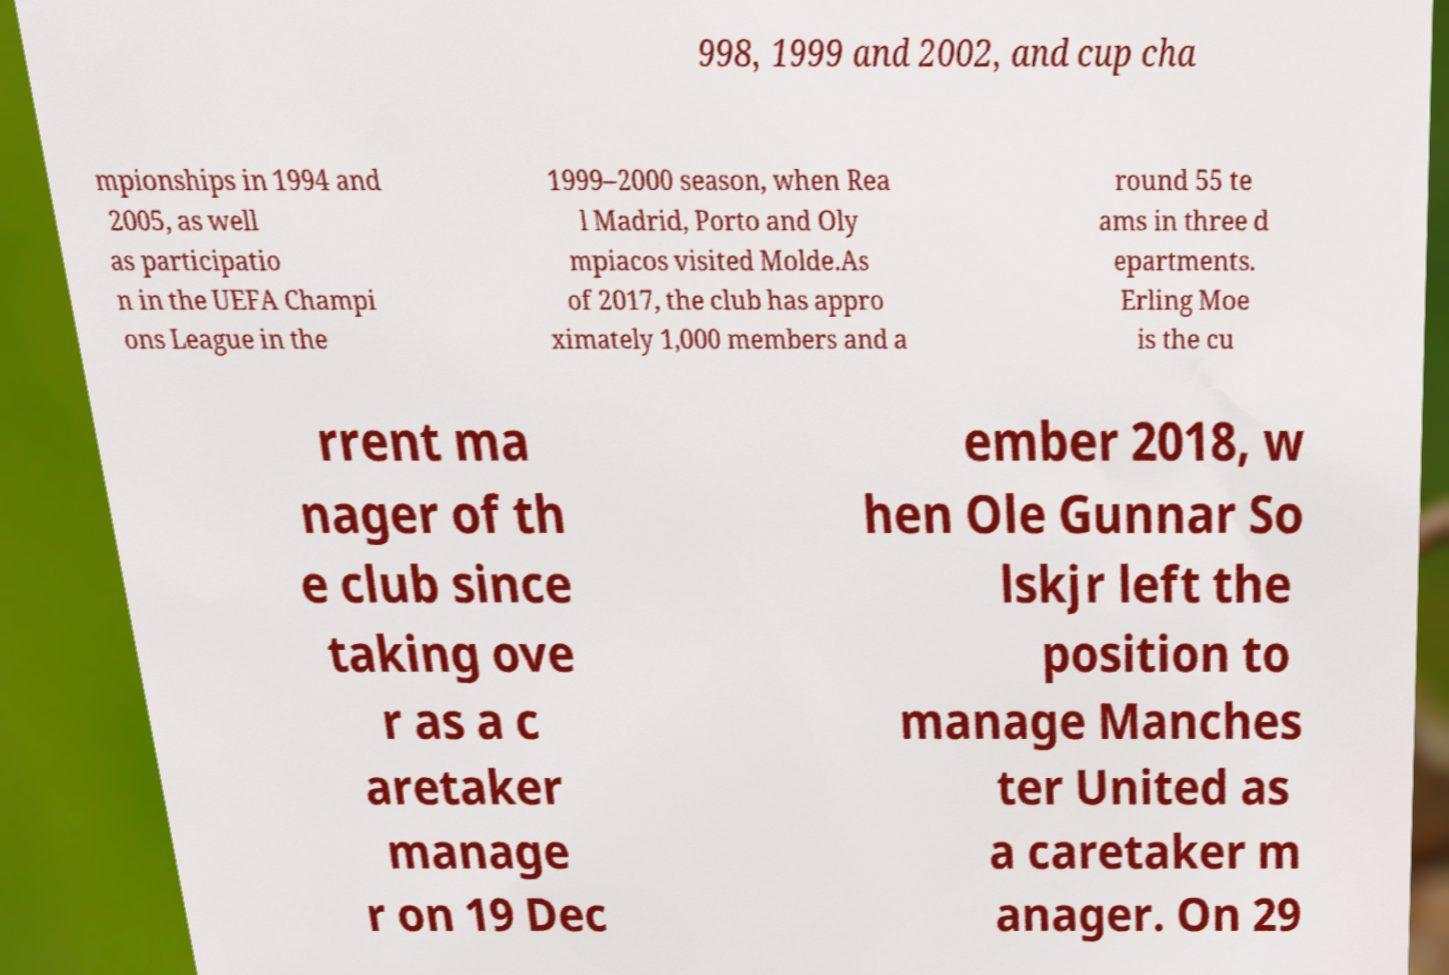I need the written content from this picture converted into text. Can you do that? 998, 1999 and 2002, and cup cha mpionships in 1994 and 2005, as well as participatio n in the UEFA Champi ons League in the 1999–2000 season, when Rea l Madrid, Porto and Oly mpiacos visited Molde.As of 2017, the club has appro ximately 1,000 members and a round 55 te ams in three d epartments. Erling Moe is the cu rrent ma nager of th e club since taking ove r as a c aretaker manage r on 19 Dec ember 2018, w hen Ole Gunnar So lskjr left the position to manage Manches ter United as a caretaker m anager. On 29 